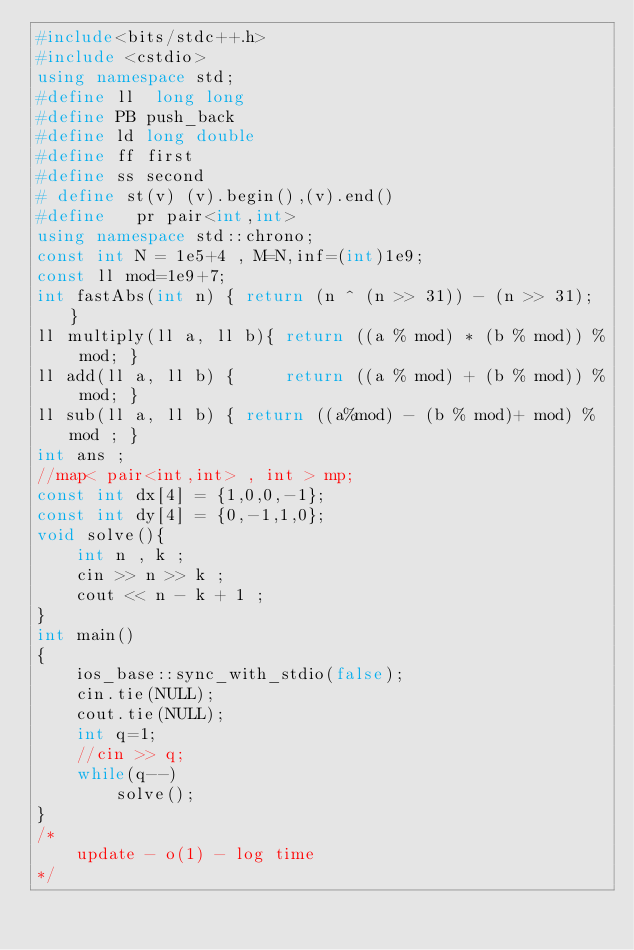Convert code to text. <code><loc_0><loc_0><loc_500><loc_500><_C++_>#include<bits/stdc++.h>
#include <cstdio>
using namespace std;
#define ll  long long
#define PB push_back
#define ld long double
#define ff first
#define ss second
# define st(v) (v).begin(),(v).end()
#define   pr pair<int,int>
using namespace std::chrono;
const int N = 1e5+4 , M=N,inf=(int)1e9;
const ll mod=1e9+7;
int fastAbs(int n) { return (n ^ (n >> 31)) - (n >> 31); }
ll multiply(ll a, ll b){ return ((a % mod) * (b % mod)) % mod; }
ll add(ll a, ll b) {     return ((a % mod) + (b % mod)) % mod; }
ll sub(ll a, ll b) { return ((a%mod) - (b % mod)+ mod) % mod ; }
int ans ;
//map< pair<int,int> , int > mp;
const int dx[4] = {1,0,0,-1};
const int dy[4] = {0,-1,1,0};
void solve(){
    int n , k ;
    cin >> n >> k ;
    cout << n - k + 1 ;
}
int main()
{
    ios_base::sync_with_stdio(false);
    cin.tie(NULL);
    cout.tie(NULL);
    int q=1;
    //cin >> q;
    while(q--)
        solve();
}
/*
    update - o(1) - log time
*/
</code> 